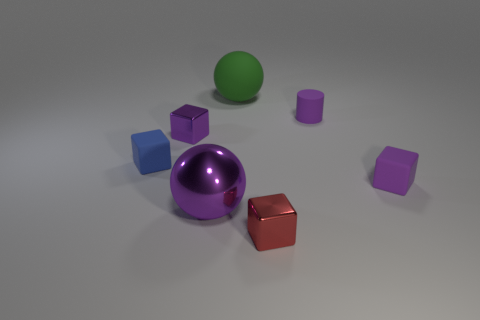Subtract all blue blocks. Subtract all green spheres. How many blocks are left? 3 Add 3 matte blocks. How many objects exist? 10 Subtract all cylinders. How many objects are left? 6 Add 4 blue blocks. How many blue blocks are left? 5 Add 1 purple metallic things. How many purple metallic things exist? 3 Subtract 0 red cylinders. How many objects are left? 7 Subtract all small purple matte things. Subtract all tiny purple cylinders. How many objects are left? 4 